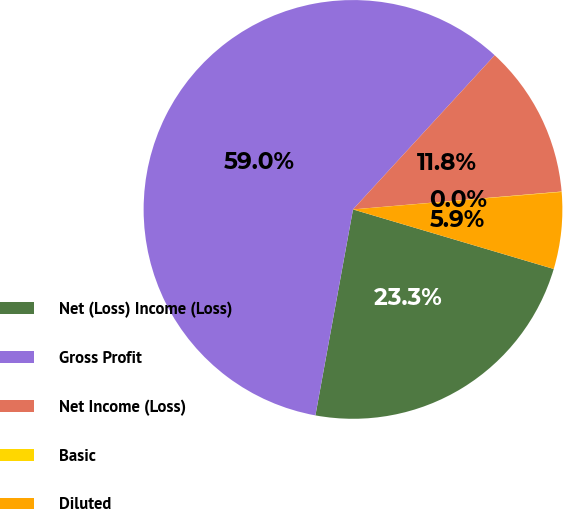Convert chart to OTSL. <chart><loc_0><loc_0><loc_500><loc_500><pie_chart><fcel>Net (Loss) Income (Loss)<fcel>Gross Profit<fcel>Net Income (Loss)<fcel>Basic<fcel>Diluted<nl><fcel>23.28%<fcel>58.95%<fcel>11.81%<fcel>0.03%<fcel>5.92%<nl></chart> 